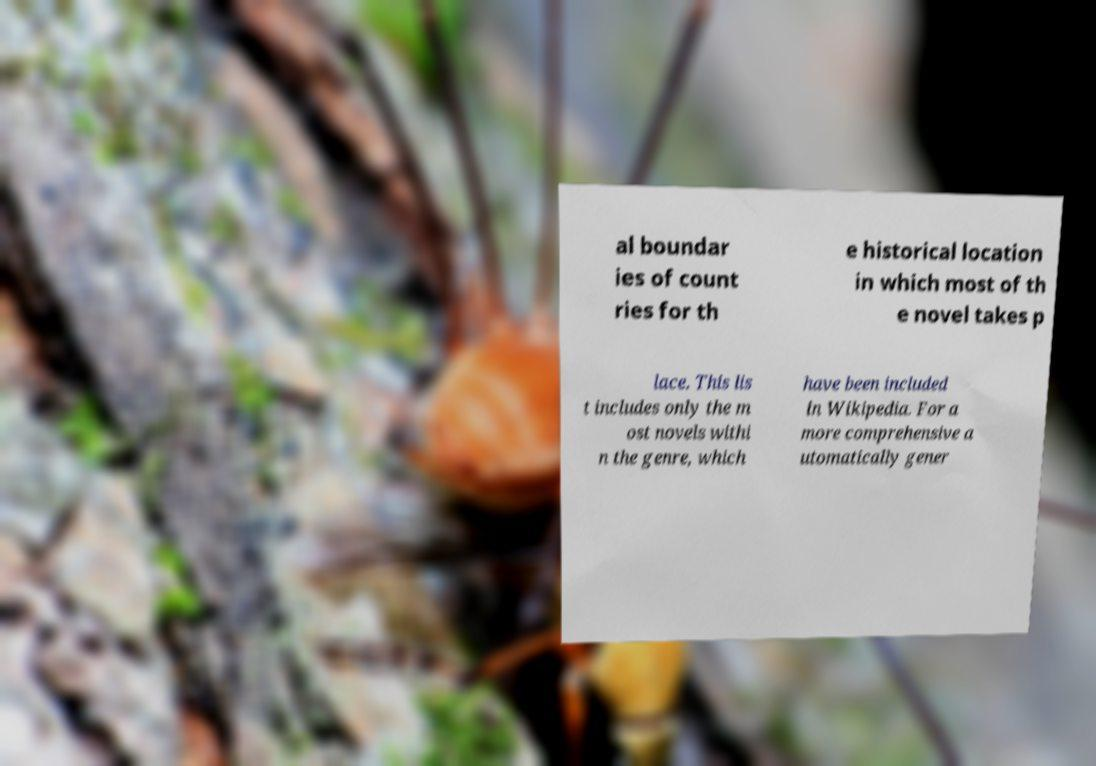I need the written content from this picture converted into text. Can you do that? al boundar ies of count ries for th e historical location in which most of th e novel takes p lace. This lis t includes only the m ost novels withi n the genre, which have been included in Wikipedia. For a more comprehensive a utomatically gener 